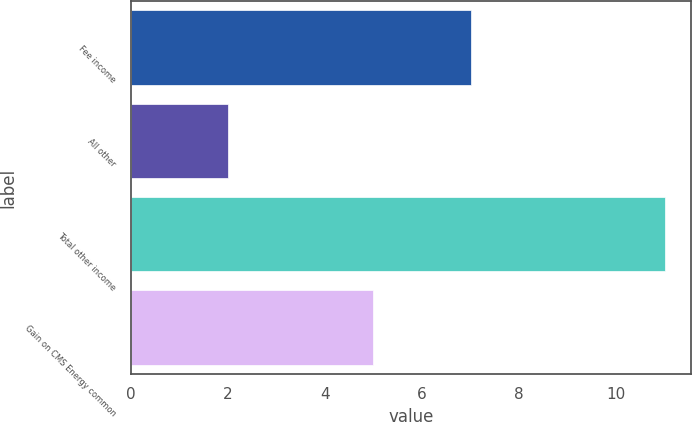Convert chart to OTSL. <chart><loc_0><loc_0><loc_500><loc_500><bar_chart><fcel>Fee income<fcel>All other<fcel>Total other income<fcel>Gain on CMS Energy common<nl><fcel>7<fcel>2<fcel>11<fcel>5<nl></chart> 